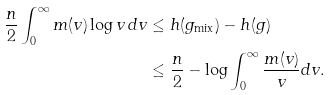Convert formula to latex. <formula><loc_0><loc_0><loc_500><loc_500>\frac { n } { 2 } \int _ { 0 } ^ { \infty } m ( v ) \log v \, d v & \leq h ( g _ { \text {mix} } ) - h ( g ) \\ & \leq \frac { n } { 2 } - \log \int _ { 0 } ^ { \infty } \frac { m ( v ) } { v } d v .</formula> 